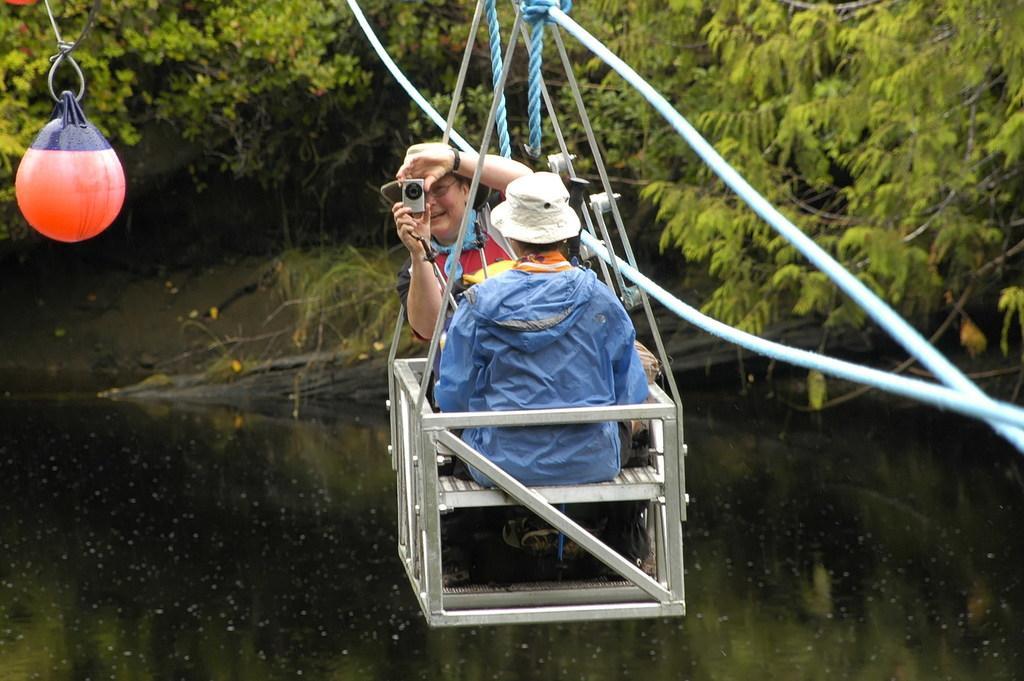Describe this image in one or two sentences. In this image we can see people sitting in the ropeway and one of them is holding a camera in the hands. In the background there are trees and water. 